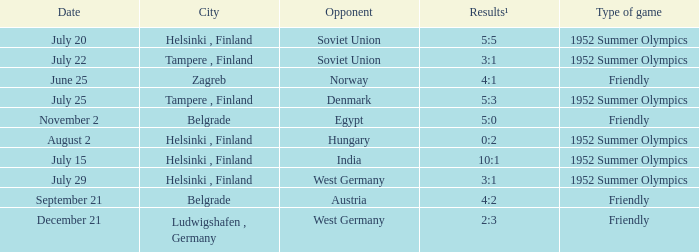What category of game took place on july 29? 1952 Summer Olympics. 